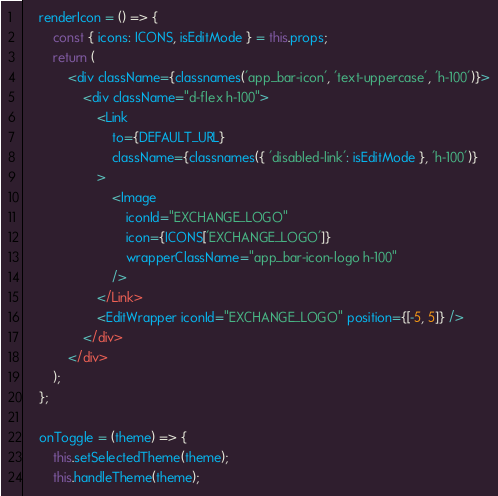<code> <loc_0><loc_0><loc_500><loc_500><_JavaScript_>	renderIcon = () => {
		const { icons: ICONS, isEditMode } = this.props;
		return (
			<div className={classnames('app_bar-icon', 'text-uppercase', 'h-100')}>
				<div className="d-flex h-100">
					<Link
						to={DEFAULT_URL}
						className={classnames({ 'disabled-link': isEditMode }, 'h-100')}
					>
						<Image
							iconId="EXCHANGE_LOGO"
							icon={ICONS['EXCHANGE_LOGO']}
							wrapperClassName="app_bar-icon-logo h-100"
						/>
					</Link>
					<EditWrapper iconId="EXCHANGE_LOGO" position={[-5, 5]} />
				</div>
			</div>
		);
	};

	onToggle = (theme) => {
		this.setSelectedTheme(theme);
		this.handleTheme(theme);</code> 